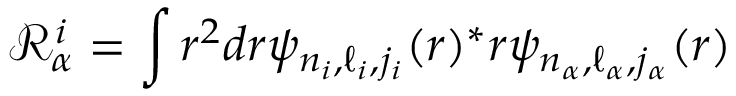Convert formula to latex. <formula><loc_0><loc_0><loc_500><loc_500>\mathcal { R } _ { \alpha } ^ { i } = \int r ^ { 2 } d r \psi _ { n _ { i } , \ell _ { i } , j _ { i } } ( r ) ^ { * } r \psi _ { n _ { \alpha } , \ell _ { \alpha } , j _ { \alpha } } ( r )</formula> 